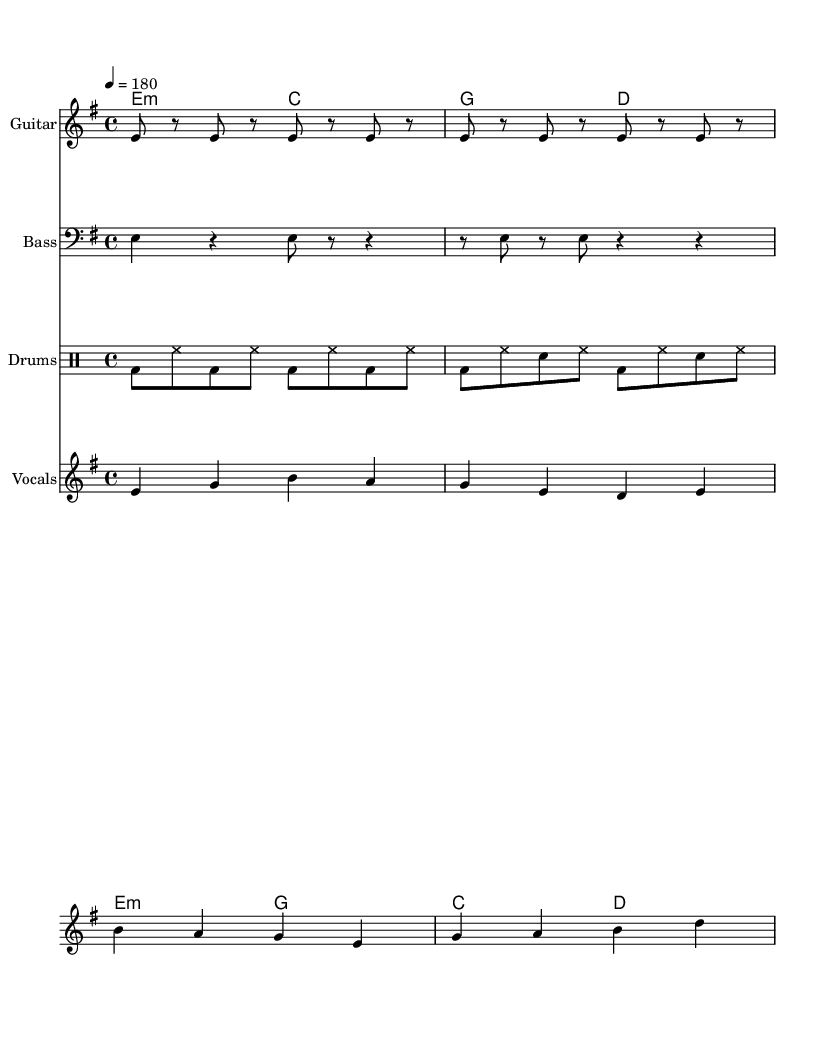What is the key signature of this music? The key signature is E minor, which has one sharp (F#). This is determined by looking for the key indication in the music.
Answer: E minor What is the time signature of this piece? The time signature is 4/4, commonly known as "common time." This is indicated at the beginning of the sheet music.
Answer: 4/4 What is the tempo marking for this score? The tempo marking is 180, indicating the speed of the music in beats per minute. It is placed at the beginning in the tempo indication.
Answer: 180 How many measures are in the guitar riff? The guitar riff consists of 8 measures, which can be counted from the notation as it repeats every 4 beats for two repetitions.
Answer: 8 What is the relationship between the verse and chorus chords? The verse chords are E minor and C major, while the chorus chords are E minor and G major. This shows a contrast in harmony and creates tension.
Answer: Contrast What is the theme addressed in the lyrics of this track? The lyrics address corporate rivalry, reflecting a competitive tone toward outdated technology in the market. This is evident from phrases referencing "cutting through the market" and "outdated gear."
Answer: Corporate rivalry What is the instrument playing the bass line? The bass line is played by the bass guitar, as indicated by the instrument name written on the staff accompanying the bass notes.
Answer: Bass 